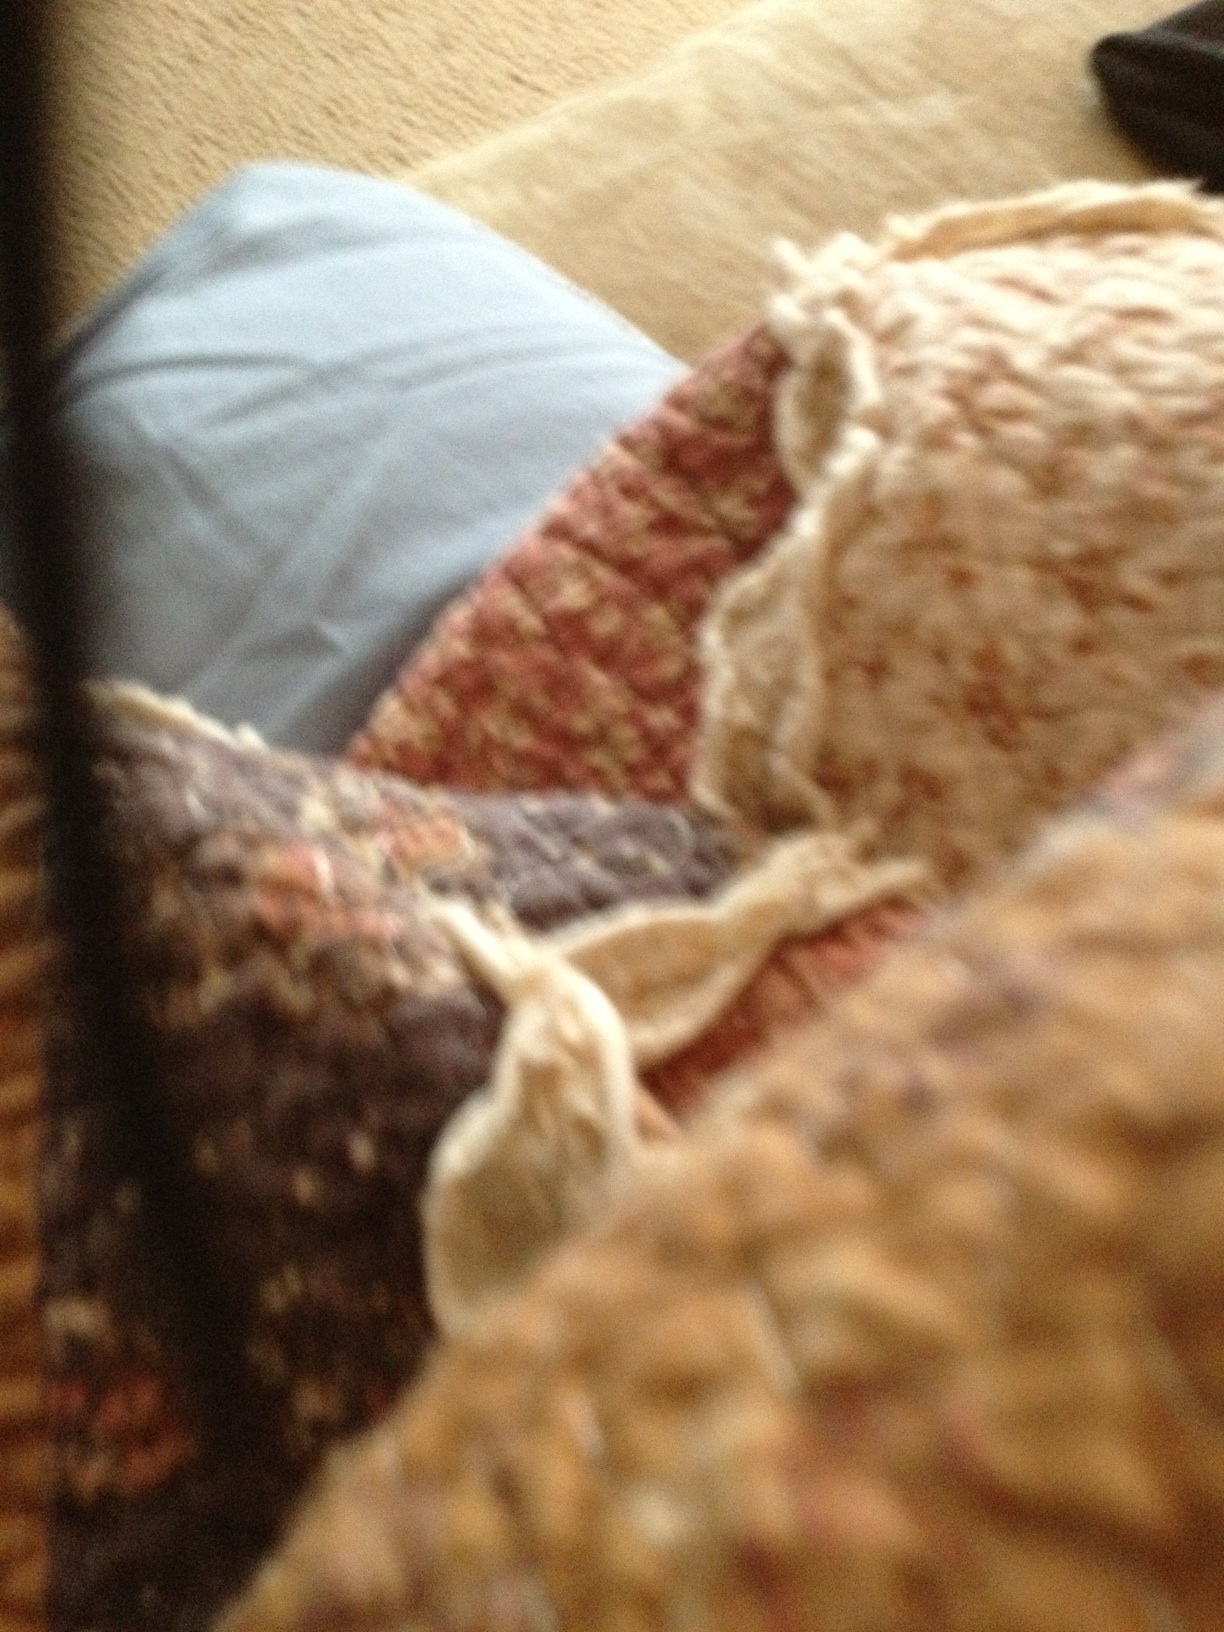What kind of room decor would this fabric complement? This fabric, with its burgundy red, cream, and blue hues, would complement a cozy, rustic room decor. It would fit perfectly in a living room with wooden furniture, warm lighting, and other textured fabrics such as knitted throws and plush cushions. The colors would also harmonize with autumnal decor, featuring elements like warm-toned leaves, candles, and antique pieces. Could this fabric be part of a modern, minimalist decor? While this fabric's rich texture and varied colors are more commonly associated with rustic or traditional styles, it could certainly be incorporated into a modern, minimalist decor if used thoughtfully. For instance, it could serve as a statement piece – a throw on a neutral-colored couch or an accent on a simple bedspread. The key would be to balance it with the minimalist elements, ensuring that it adds a touch of warmth and character without overwhelming the clean lines and simplicity of the modern design. Imagine that the pattern on this fabric inspires an entire fashion collection. What themes or styles would emerge? Inspired by the pattern on this fabric, a fashion collection could emerge with themes of comfort and timeless elegance. The collection might feature cozy knitwear in rich burgundy and creamy hues, blending textures to evoke a sense of warmth. Styles could include oversized sweaters, textured scarves, and woven accessories like bags and hats. The pieces would be designed to bring a rustic charm to modern wardrobes, combining tradition with contemporary cuts and silhouettes. Elements of handcrafted detailing, such as embroidery or patchwork, might also be present to highlight the artisanal inspiration behind the collection. 